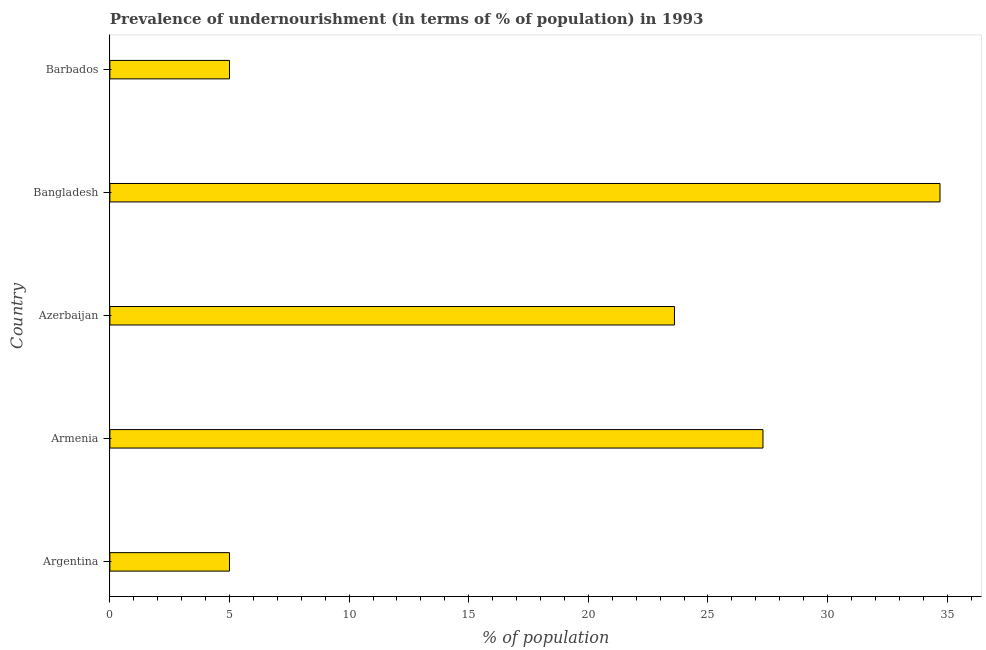What is the title of the graph?
Give a very brief answer. Prevalence of undernourishment (in terms of % of population) in 1993. What is the label or title of the X-axis?
Keep it short and to the point. % of population. What is the label or title of the Y-axis?
Your answer should be compact. Country. Across all countries, what is the maximum percentage of undernourished population?
Provide a short and direct response. 34.7. In which country was the percentage of undernourished population minimum?
Your answer should be compact. Argentina. What is the sum of the percentage of undernourished population?
Offer a terse response. 95.6. What is the difference between the percentage of undernourished population in Bangladesh and Barbados?
Offer a terse response. 29.7. What is the average percentage of undernourished population per country?
Ensure brevity in your answer.  19.12. What is the median percentage of undernourished population?
Offer a very short reply. 23.6. What is the ratio of the percentage of undernourished population in Armenia to that in Bangladesh?
Offer a very short reply. 0.79. Is the difference between the percentage of undernourished population in Bangladesh and Barbados greater than the difference between any two countries?
Ensure brevity in your answer.  Yes. Is the sum of the percentage of undernourished population in Argentina and Barbados greater than the maximum percentage of undernourished population across all countries?
Offer a very short reply. No. What is the difference between the highest and the lowest percentage of undernourished population?
Give a very brief answer. 29.7. How many bars are there?
Give a very brief answer. 5. How many countries are there in the graph?
Make the answer very short. 5. What is the difference between two consecutive major ticks on the X-axis?
Make the answer very short. 5. What is the % of population of Argentina?
Your response must be concise. 5. What is the % of population in Armenia?
Make the answer very short. 27.3. What is the % of population in Azerbaijan?
Your answer should be very brief. 23.6. What is the % of population of Bangladesh?
Keep it short and to the point. 34.7. What is the difference between the % of population in Argentina and Armenia?
Your answer should be compact. -22.3. What is the difference between the % of population in Argentina and Azerbaijan?
Offer a very short reply. -18.6. What is the difference between the % of population in Argentina and Bangladesh?
Offer a terse response. -29.7. What is the difference between the % of population in Argentina and Barbados?
Your answer should be compact. 0. What is the difference between the % of population in Armenia and Barbados?
Keep it short and to the point. 22.3. What is the difference between the % of population in Azerbaijan and Bangladesh?
Offer a terse response. -11.1. What is the difference between the % of population in Azerbaijan and Barbados?
Keep it short and to the point. 18.6. What is the difference between the % of population in Bangladesh and Barbados?
Your response must be concise. 29.7. What is the ratio of the % of population in Argentina to that in Armenia?
Keep it short and to the point. 0.18. What is the ratio of the % of population in Argentina to that in Azerbaijan?
Offer a terse response. 0.21. What is the ratio of the % of population in Argentina to that in Bangladesh?
Offer a terse response. 0.14. What is the ratio of the % of population in Argentina to that in Barbados?
Keep it short and to the point. 1. What is the ratio of the % of population in Armenia to that in Azerbaijan?
Provide a succinct answer. 1.16. What is the ratio of the % of population in Armenia to that in Bangladesh?
Offer a very short reply. 0.79. What is the ratio of the % of population in Armenia to that in Barbados?
Keep it short and to the point. 5.46. What is the ratio of the % of population in Azerbaijan to that in Bangladesh?
Ensure brevity in your answer.  0.68. What is the ratio of the % of population in Azerbaijan to that in Barbados?
Provide a succinct answer. 4.72. What is the ratio of the % of population in Bangladesh to that in Barbados?
Your answer should be very brief. 6.94. 